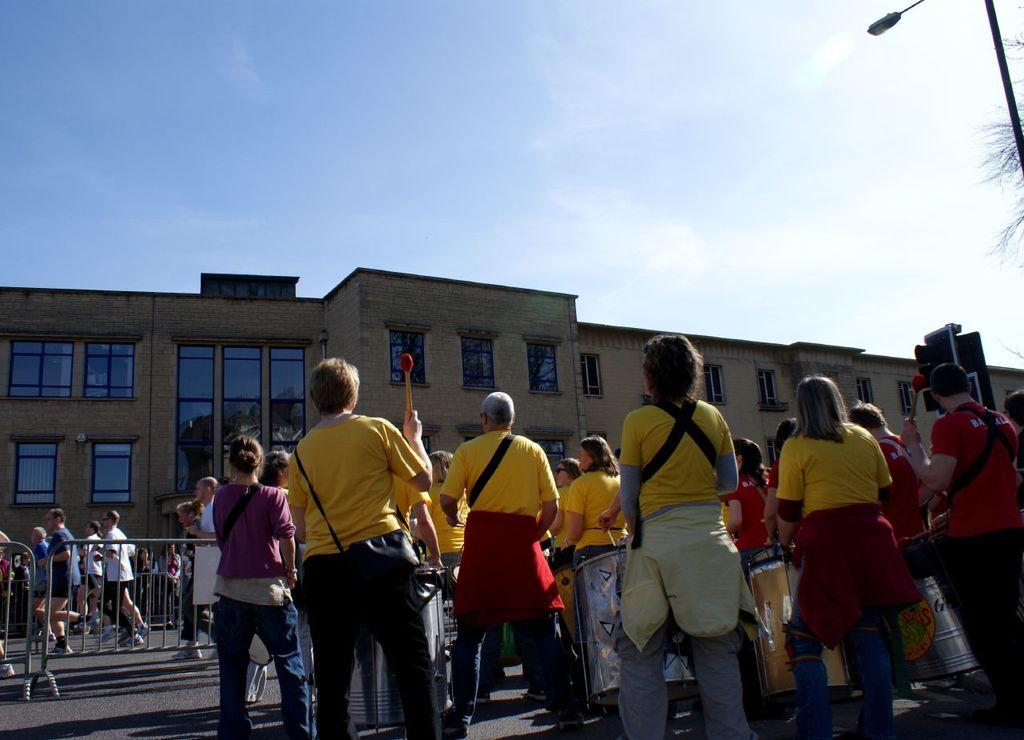What are the people in the image doing? The people in the image are standing on the road. What type of structure can be seen in the image? There is a building with windows in the image. What is the purpose of the fence in the image? The fence in the image serves as a barrier or boundary. What is the tall, vertical object in the image? There is a light pole in the image. What can be seen in the background of the image? The sky is visible in the background of the image. What type of flower is growing on the light pole in the image? There are no flowers present on the light pole in the image. How does the frame of the building affect the image? There is no frame mentioned in the image, as it is a photograph or digital representation and not a physical object with a frame. 